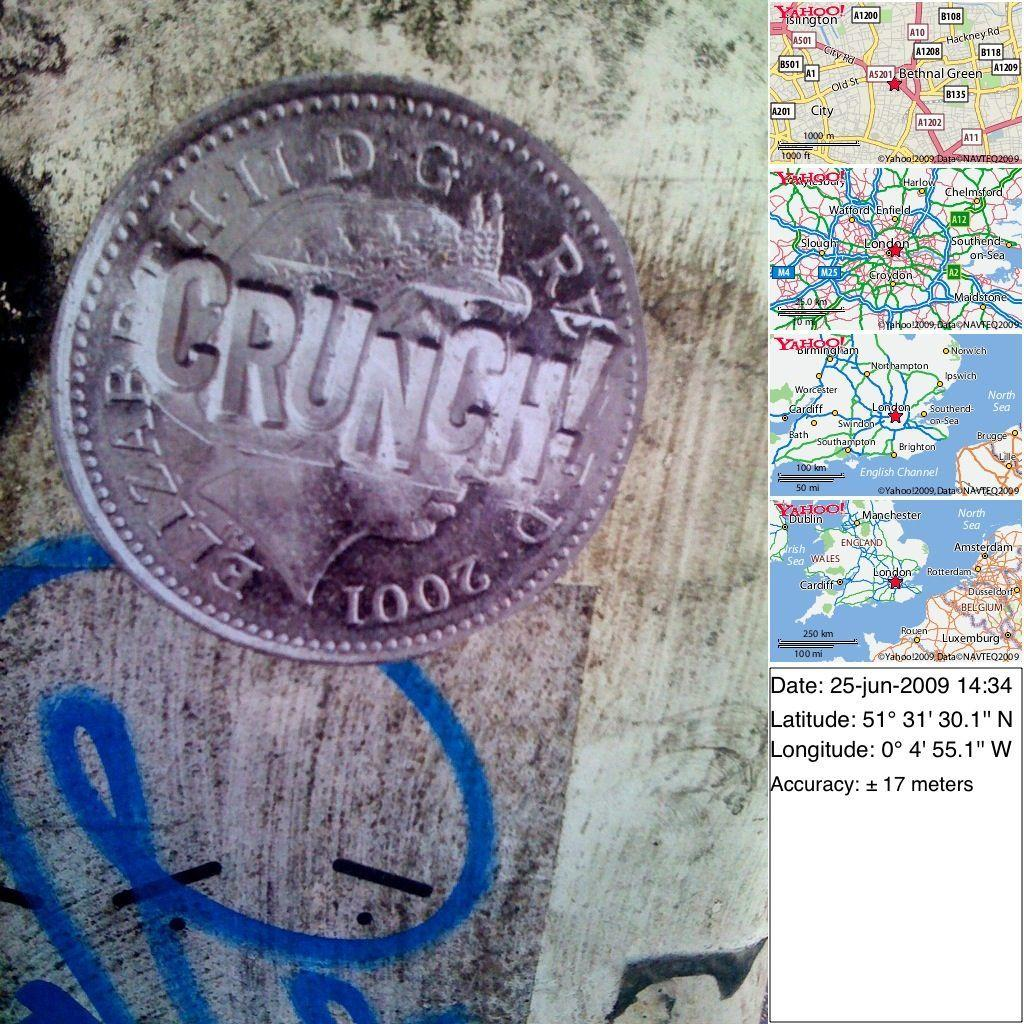Provide a one-sentence caption for the provided image. Several small maps and a coin that says Crunch. 